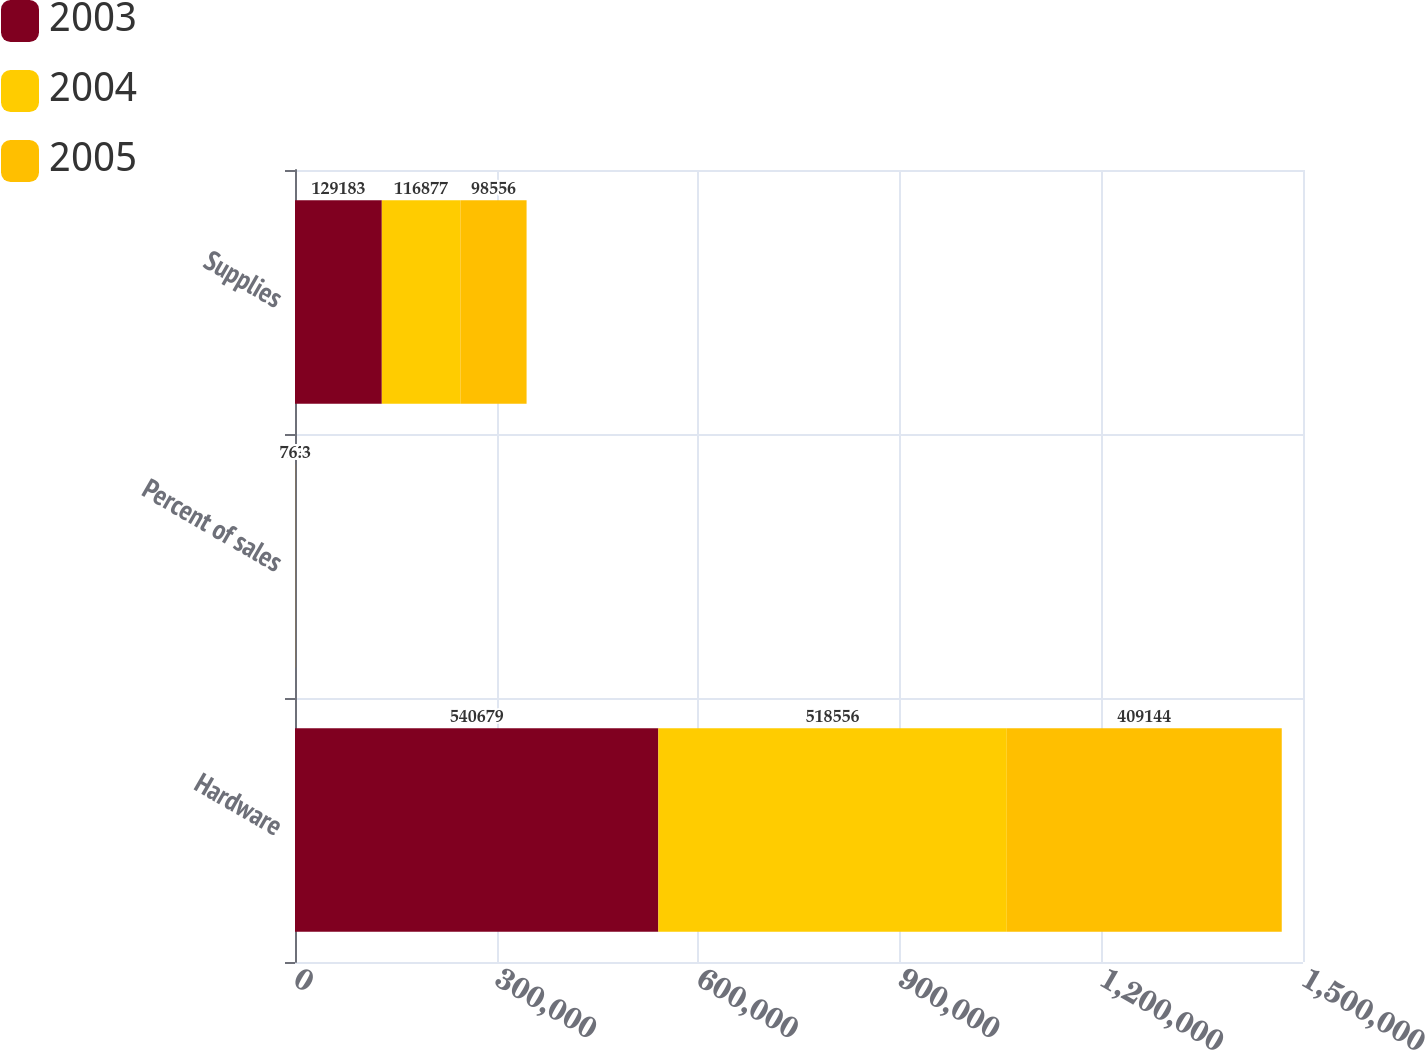Convert chart to OTSL. <chart><loc_0><loc_0><loc_500><loc_500><stacked_bar_chart><ecel><fcel>Hardware<fcel>Percent of sales<fcel>Supplies<nl><fcel>2003<fcel>540679<fcel>77<fcel>129183<nl><fcel>2004<fcel>518556<fcel>78.2<fcel>116877<nl><fcel>2005<fcel>409144<fcel>76.3<fcel>98556<nl></chart> 